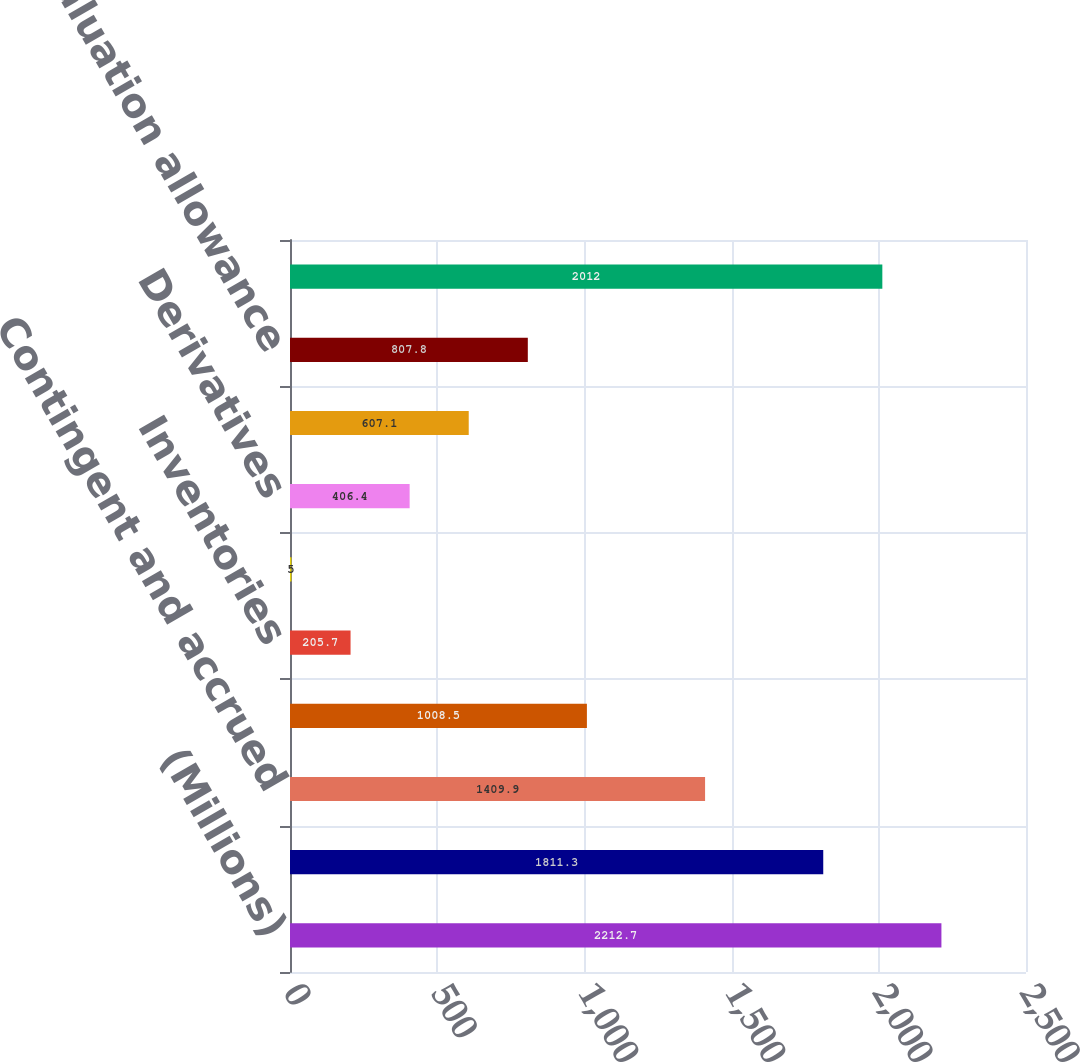Convert chart. <chart><loc_0><loc_0><loc_500><loc_500><bar_chart><fcel>(Millions)<fcel>Employee benefits<fcel>Contingent and accrued<fcel>Operating loss and other<fcel>Inventories<fcel>Property<fcel>Derivatives<fcel>Other<fcel>Valuation allowance<fcel>Total<nl><fcel>2212.7<fcel>1811.3<fcel>1409.9<fcel>1008.5<fcel>205.7<fcel>5<fcel>406.4<fcel>607.1<fcel>807.8<fcel>2012<nl></chart> 